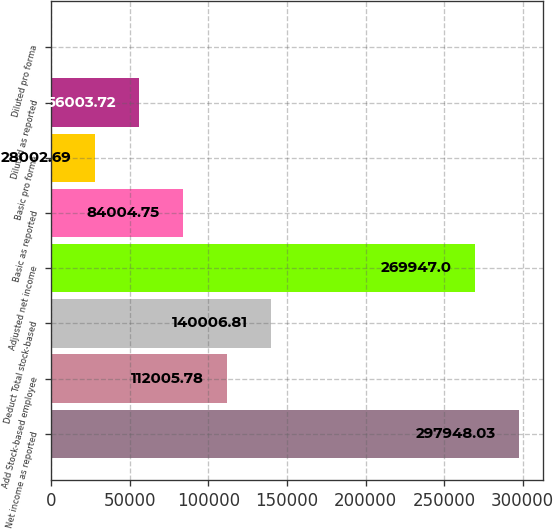Convert chart. <chart><loc_0><loc_0><loc_500><loc_500><bar_chart><fcel>Net income as reported<fcel>Add Stock-based employee<fcel>Deduct Total stock-based<fcel>Adjusted net income<fcel>Basic as reported<fcel>Basic pro forma<fcel>Diluted as reported<fcel>Diluted pro forma<nl><fcel>297948<fcel>112006<fcel>140007<fcel>269947<fcel>84004.8<fcel>28002.7<fcel>56003.7<fcel>1.66<nl></chart> 